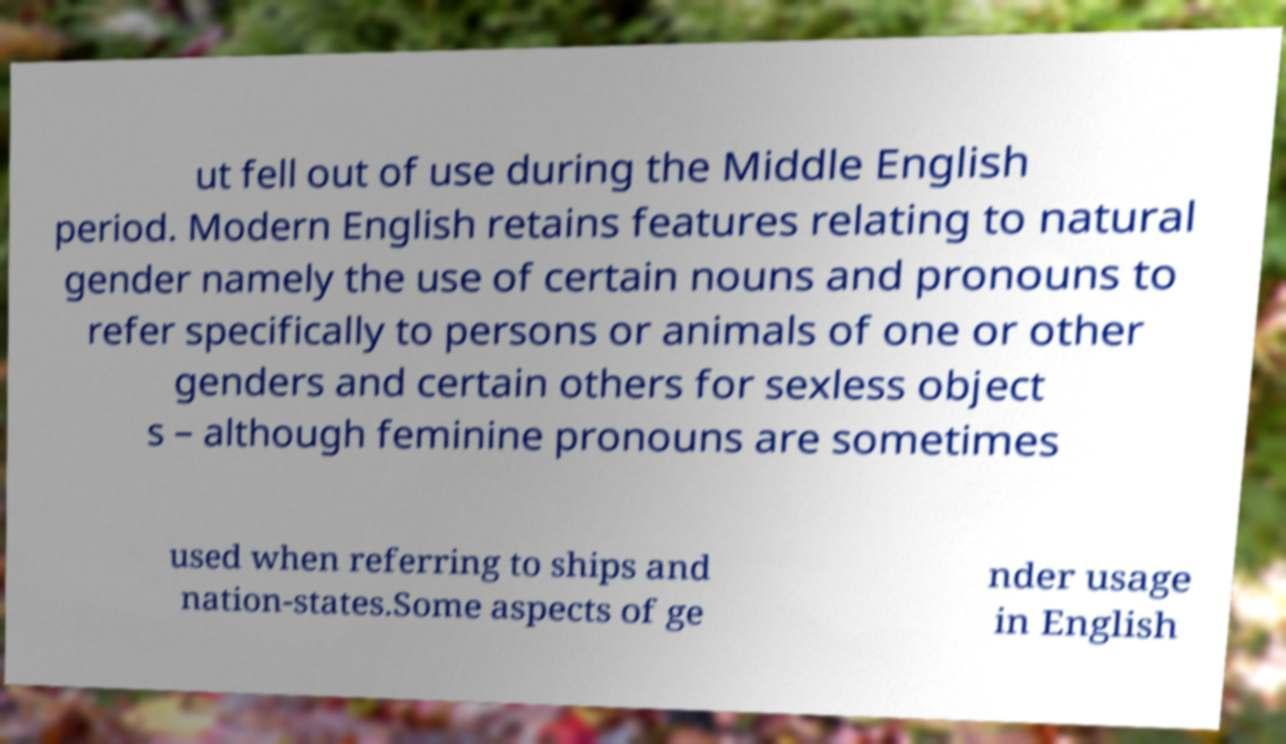Could you extract and type out the text from this image? ut fell out of use during the Middle English period. Modern English retains features relating to natural gender namely the use of certain nouns and pronouns to refer specifically to persons or animals of one or other genders and certain others for sexless object s – although feminine pronouns are sometimes used when referring to ships and nation-states.Some aspects of ge nder usage in English 